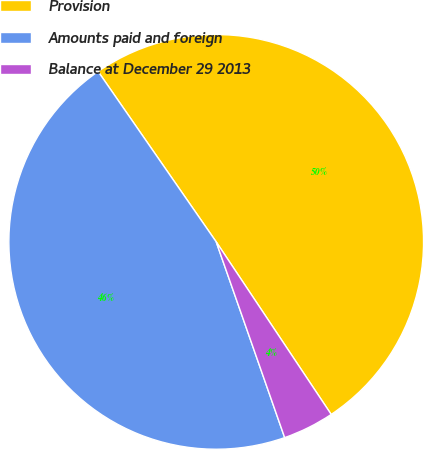Convert chart to OTSL. <chart><loc_0><loc_0><loc_500><loc_500><pie_chart><fcel>Provision<fcel>Amounts paid and foreign<fcel>Balance at December 29 2013<nl><fcel>50.29%<fcel>45.71%<fcel>4.0%<nl></chart> 